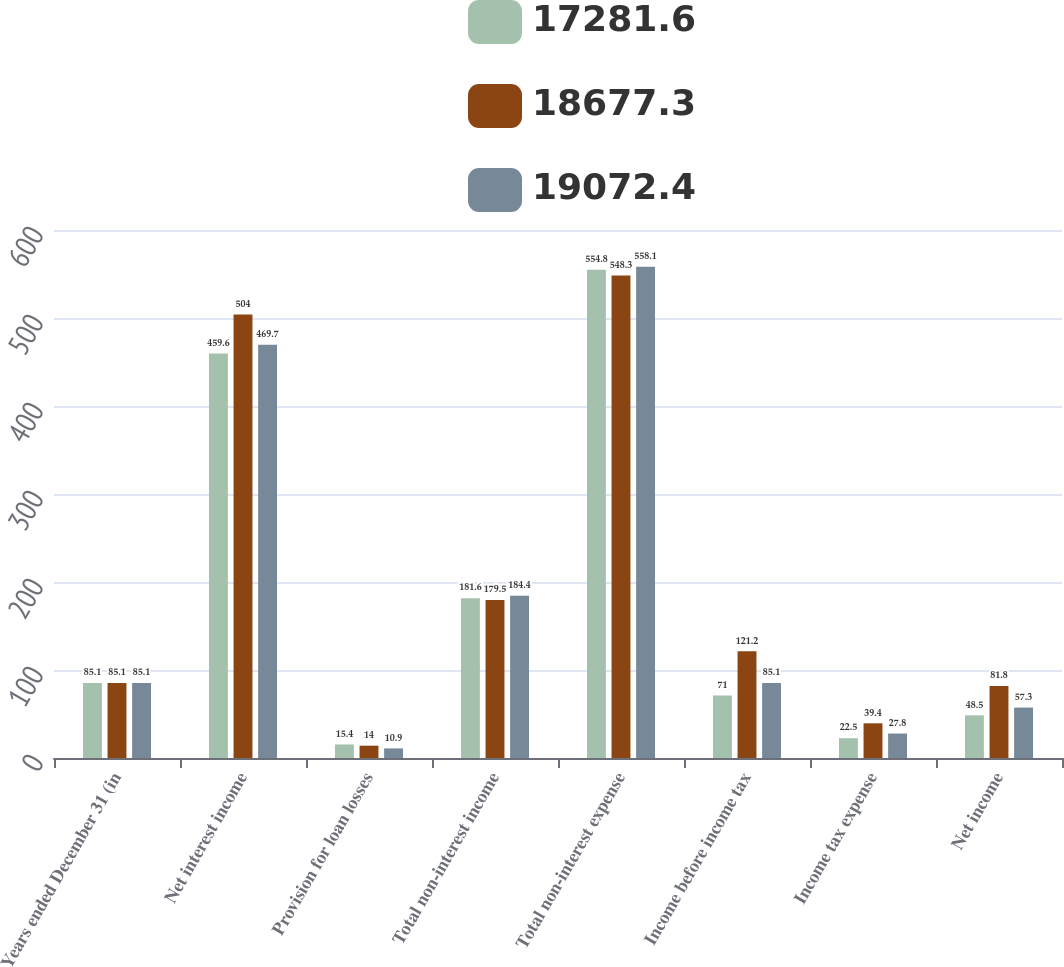<chart> <loc_0><loc_0><loc_500><loc_500><stacked_bar_chart><ecel><fcel>Years ended December 31 (in<fcel>Net interest income<fcel>Provision for loan losses<fcel>Total non-interest income<fcel>Total non-interest expense<fcel>Income before income tax<fcel>Income tax expense<fcel>Net income<nl><fcel>17281.6<fcel>85.1<fcel>459.6<fcel>15.4<fcel>181.6<fcel>554.8<fcel>71<fcel>22.5<fcel>48.5<nl><fcel>18677.3<fcel>85.1<fcel>504<fcel>14<fcel>179.5<fcel>548.3<fcel>121.2<fcel>39.4<fcel>81.8<nl><fcel>19072.4<fcel>85.1<fcel>469.7<fcel>10.9<fcel>184.4<fcel>558.1<fcel>85.1<fcel>27.8<fcel>57.3<nl></chart> 